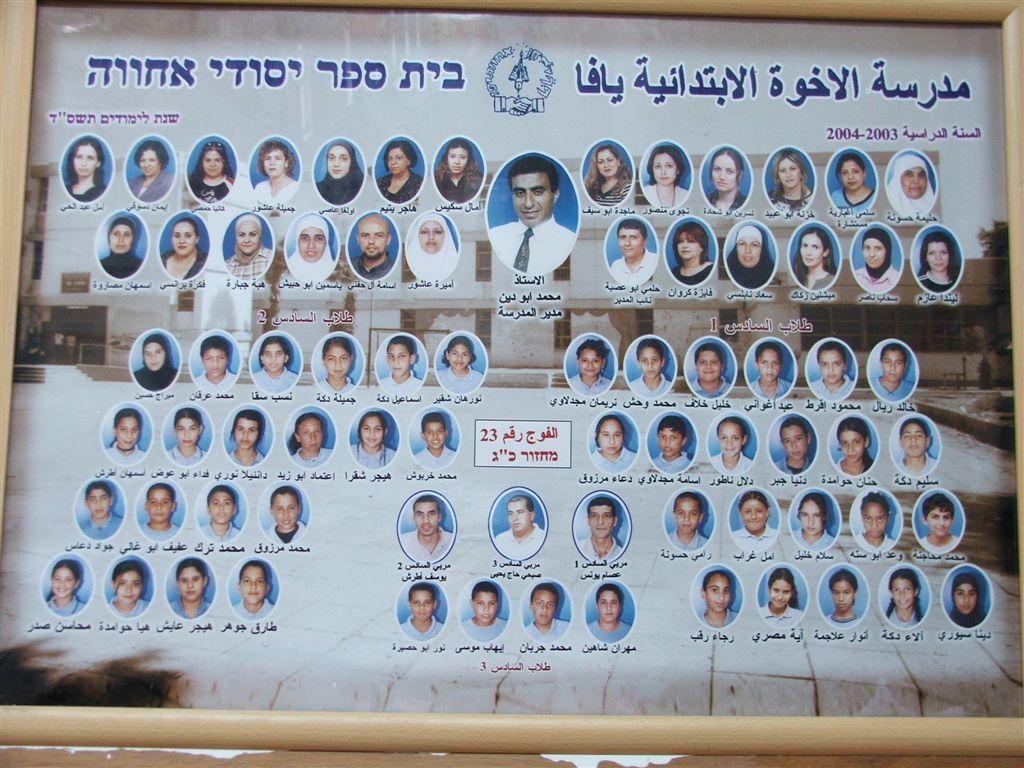What is the main object in the image? There is a poster in the image. What can be seen on the poster? The poster contains images of people and text. Is there any specific design element on the poster? Yes, there is a logo at the top middle of the poster. Can you tell me how many snails are crawling on the poster in the image? There are no snails present on the poster in the image. What is the plot of the story depicted on the poster? The poster does not depict a story, so there is no plot to describe. 